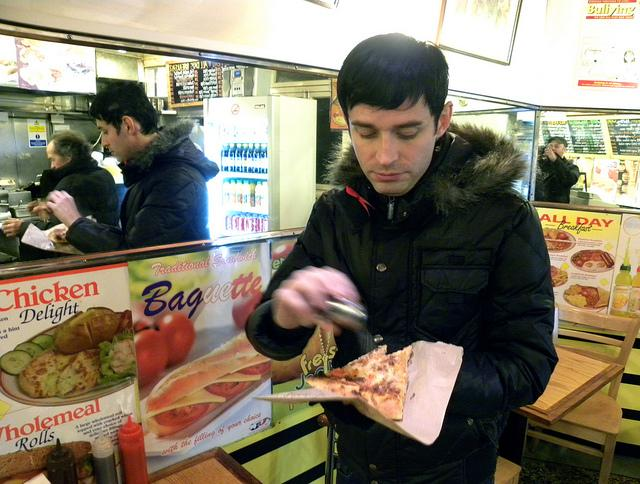What is he doing with the pizza? seasoning 